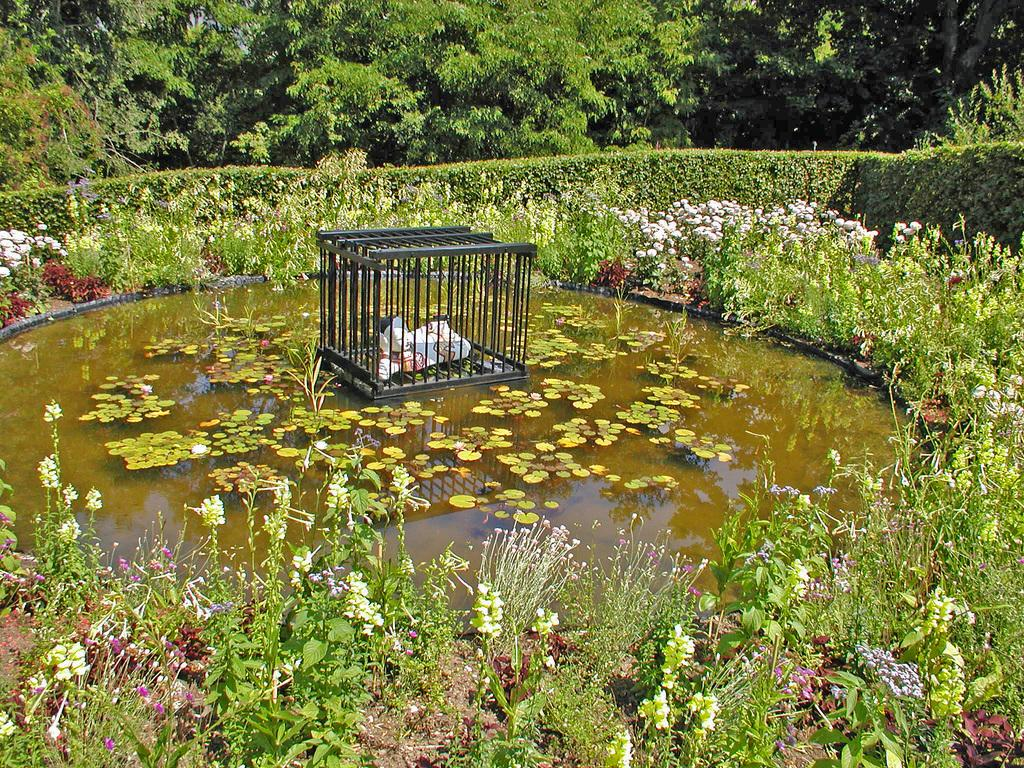What is located in the pond in the center of the image? There is a cage in the pond in the center of the image. What can be seen at the bottom of the image? There are flowers and plants at the bottom of the image. What is visible in the background of the image? There are trees and fencing in the background of the image. What else can be seen in the background of the image? There are additional plants and flowers in the background of the image. What type of horn can be seen on the volcano in the image? There is no volcano or horn present in the image. What shape is the square pond in the image? There is no square pond in the image; the pond is not described as having a square shape. 